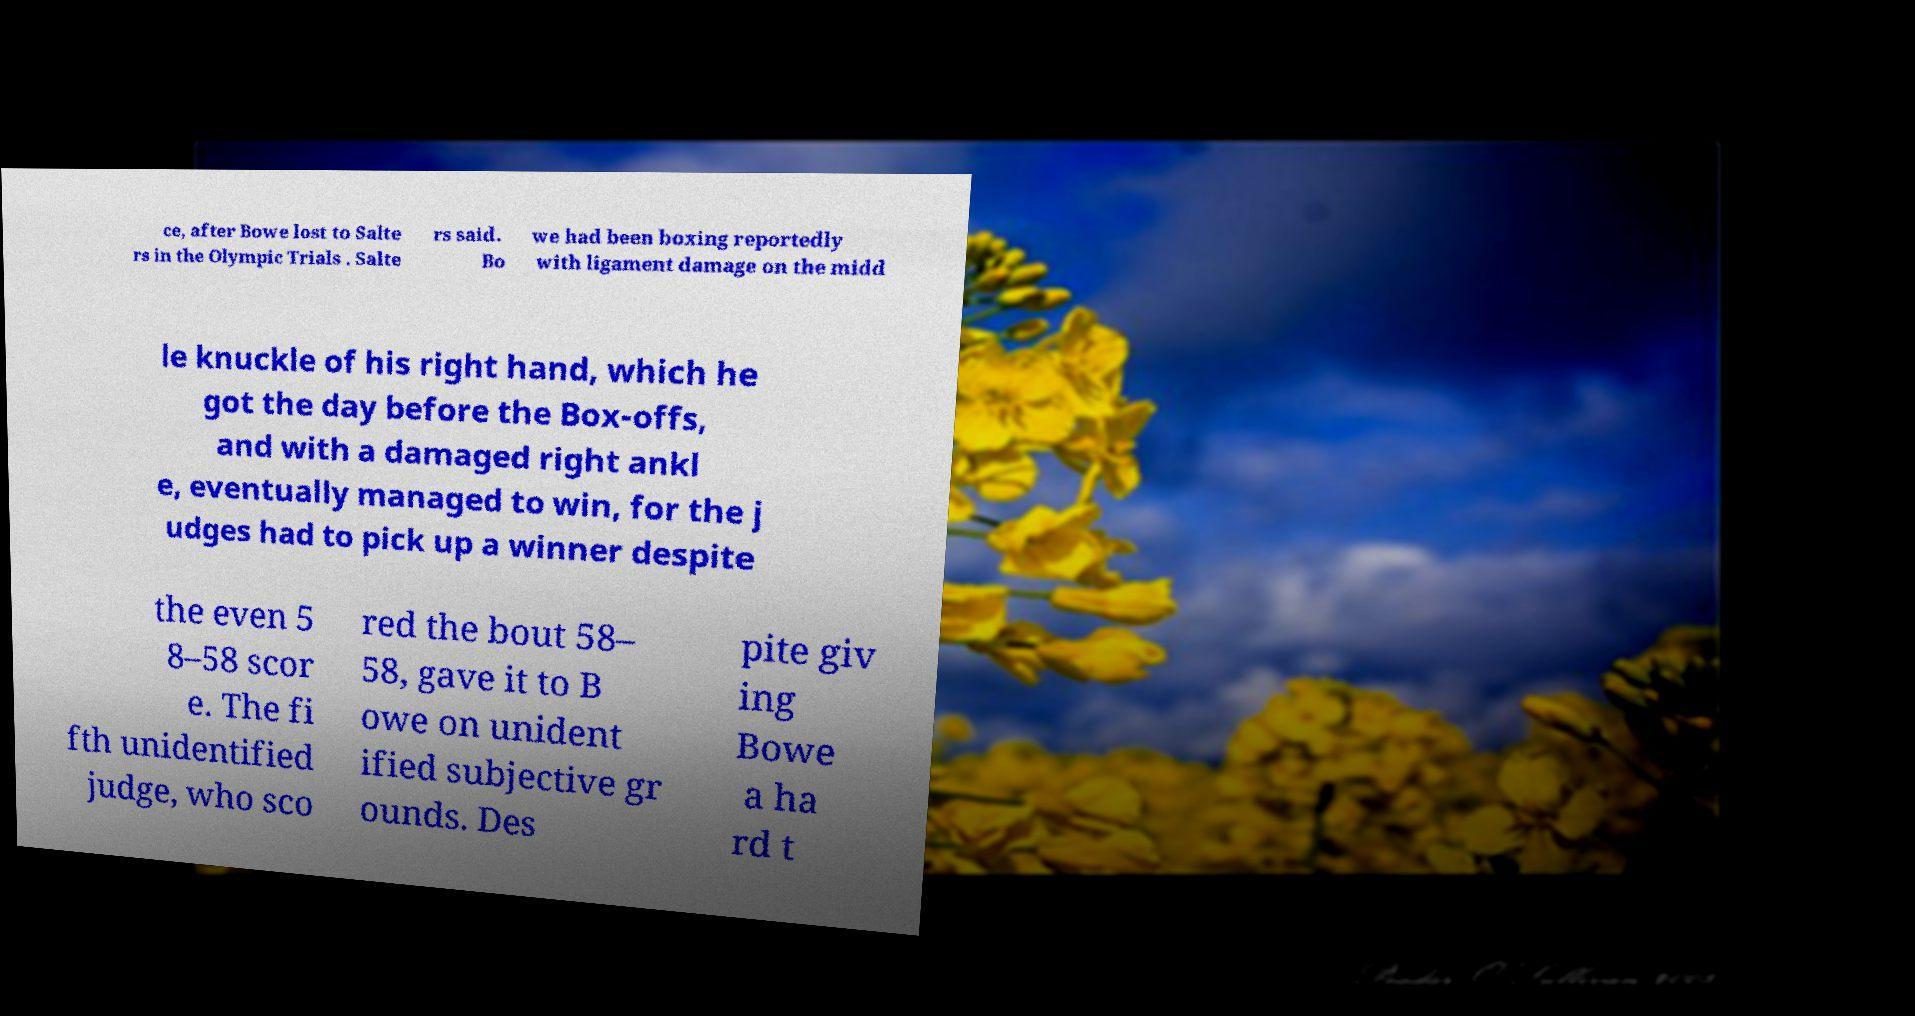For documentation purposes, I need the text within this image transcribed. Could you provide that? ce, after Bowe lost to Salte rs in the Olympic Trials . Salte rs said. Bo we had been boxing reportedly with ligament damage on the midd le knuckle of his right hand, which he got the day before the Box-offs, and with a damaged right ankl e, eventually managed to win, for the j udges had to pick up a winner despite the even 5 8–58 scor e. The fi fth unidentified judge, who sco red the bout 58– 58, gave it to B owe on unident ified subjective gr ounds. Des pite giv ing Bowe a ha rd t 